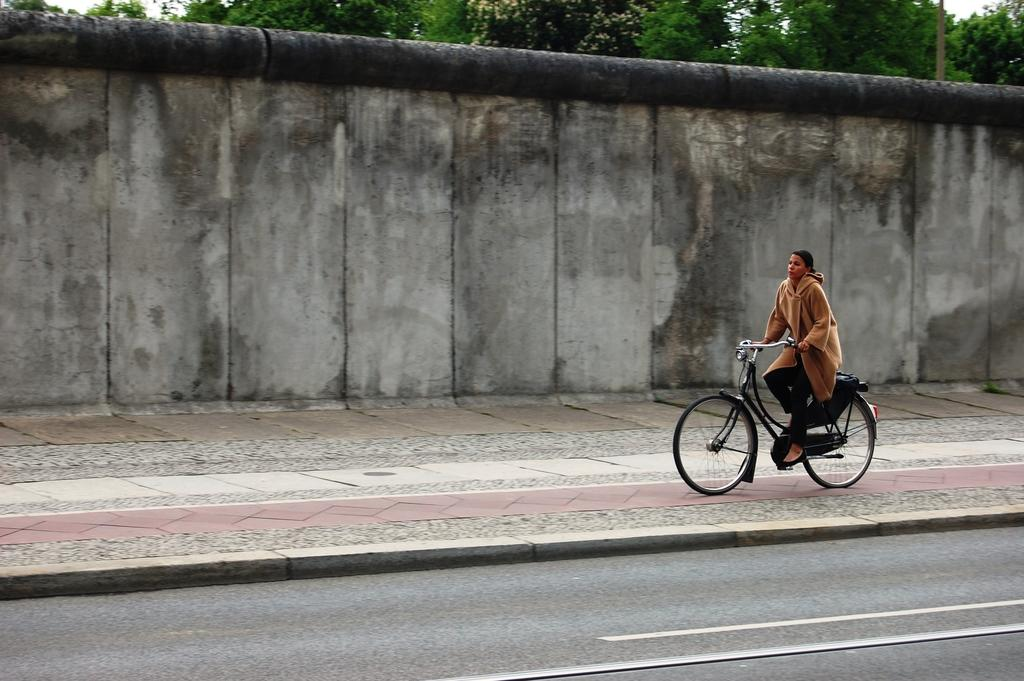Who is the main subject in the image? There is a man in the image. What is the man doing in the image? The man is riding a bicycle. What can be seen in the background of the image? There is a road, a wall, and a tree in the image. What type of system is the man using to ride the bicycle in the image? The image does not provide information about any specific system being used for the man to ride the bicycle. Can you see the ground in the image? Yes, the road in the image suggests that there is a ground beneath it. 